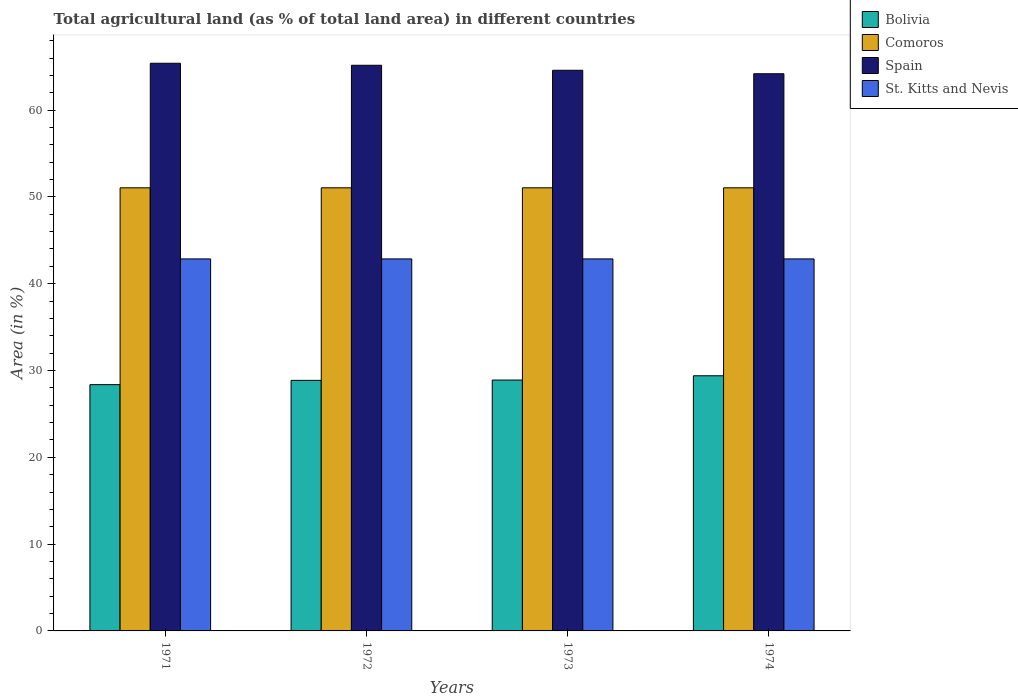How many different coloured bars are there?
Offer a very short reply. 4. What is the label of the 1st group of bars from the left?
Your answer should be compact. 1971. What is the percentage of agricultural land in Comoros in 1974?
Your response must be concise. 51.05. Across all years, what is the maximum percentage of agricultural land in Bolivia?
Your answer should be compact. 29.39. Across all years, what is the minimum percentage of agricultural land in Bolivia?
Offer a very short reply. 28.37. In which year was the percentage of agricultural land in St. Kitts and Nevis minimum?
Make the answer very short. 1971. What is the total percentage of agricultural land in Comoros in the graph?
Keep it short and to the point. 204.19. What is the difference between the percentage of agricultural land in Comoros in 1974 and the percentage of agricultural land in Bolivia in 1972?
Provide a short and direct response. 22.18. What is the average percentage of agricultural land in St. Kitts and Nevis per year?
Ensure brevity in your answer.  42.86. In the year 1971, what is the difference between the percentage of agricultural land in Bolivia and percentage of agricultural land in Spain?
Provide a succinct answer. -37.03. In how many years, is the percentage of agricultural land in Bolivia greater than 12 %?
Offer a terse response. 4. What is the ratio of the percentage of agricultural land in Comoros in 1971 to that in 1972?
Your response must be concise. 1. Is the difference between the percentage of agricultural land in Bolivia in 1973 and 1974 greater than the difference between the percentage of agricultural land in Spain in 1973 and 1974?
Offer a terse response. No. What is the difference between the highest and the second highest percentage of agricultural land in Comoros?
Provide a short and direct response. 0. Is the sum of the percentage of agricultural land in St. Kitts and Nevis in 1972 and 1973 greater than the maximum percentage of agricultural land in Comoros across all years?
Make the answer very short. Yes. Is it the case that in every year, the sum of the percentage of agricultural land in Bolivia and percentage of agricultural land in Comoros is greater than the sum of percentage of agricultural land in Spain and percentage of agricultural land in St. Kitts and Nevis?
Your response must be concise. No. What does the 1st bar from the left in 1971 represents?
Give a very brief answer. Bolivia. What does the 2nd bar from the right in 1972 represents?
Give a very brief answer. Spain. Are all the bars in the graph horizontal?
Your response must be concise. No. What is the difference between two consecutive major ticks on the Y-axis?
Provide a succinct answer. 10. Does the graph contain grids?
Provide a succinct answer. No. What is the title of the graph?
Offer a very short reply. Total agricultural land (as % of total land area) in different countries. What is the label or title of the X-axis?
Your response must be concise. Years. What is the label or title of the Y-axis?
Your response must be concise. Area (in %). What is the Area (in %) in Bolivia in 1971?
Provide a short and direct response. 28.37. What is the Area (in %) in Comoros in 1971?
Your response must be concise. 51.05. What is the Area (in %) in Spain in 1971?
Offer a very short reply. 65.4. What is the Area (in %) in St. Kitts and Nevis in 1971?
Your answer should be compact. 42.86. What is the Area (in %) of Bolivia in 1972?
Provide a short and direct response. 28.87. What is the Area (in %) in Comoros in 1972?
Your answer should be compact. 51.05. What is the Area (in %) of Spain in 1972?
Your answer should be compact. 65.16. What is the Area (in %) of St. Kitts and Nevis in 1972?
Ensure brevity in your answer.  42.86. What is the Area (in %) in Bolivia in 1973?
Make the answer very short. 28.9. What is the Area (in %) in Comoros in 1973?
Your answer should be compact. 51.05. What is the Area (in %) in Spain in 1973?
Ensure brevity in your answer.  64.59. What is the Area (in %) of St. Kitts and Nevis in 1973?
Provide a succinct answer. 42.86. What is the Area (in %) of Bolivia in 1974?
Make the answer very short. 29.39. What is the Area (in %) in Comoros in 1974?
Keep it short and to the point. 51.05. What is the Area (in %) of Spain in 1974?
Offer a terse response. 64.19. What is the Area (in %) of St. Kitts and Nevis in 1974?
Keep it short and to the point. 42.86. Across all years, what is the maximum Area (in %) of Bolivia?
Offer a terse response. 29.39. Across all years, what is the maximum Area (in %) in Comoros?
Make the answer very short. 51.05. Across all years, what is the maximum Area (in %) of Spain?
Give a very brief answer. 65.4. Across all years, what is the maximum Area (in %) of St. Kitts and Nevis?
Your response must be concise. 42.86. Across all years, what is the minimum Area (in %) of Bolivia?
Provide a short and direct response. 28.37. Across all years, what is the minimum Area (in %) in Comoros?
Give a very brief answer. 51.05. Across all years, what is the minimum Area (in %) of Spain?
Your answer should be compact. 64.19. Across all years, what is the minimum Area (in %) of St. Kitts and Nevis?
Provide a short and direct response. 42.86. What is the total Area (in %) in Bolivia in the graph?
Offer a very short reply. 115.53. What is the total Area (in %) in Comoros in the graph?
Offer a terse response. 204.19. What is the total Area (in %) of Spain in the graph?
Keep it short and to the point. 259.34. What is the total Area (in %) in St. Kitts and Nevis in the graph?
Give a very brief answer. 171.43. What is the difference between the Area (in %) of Bolivia in 1971 and that in 1972?
Make the answer very short. -0.49. What is the difference between the Area (in %) in Spain in 1971 and that in 1972?
Offer a very short reply. 0.23. What is the difference between the Area (in %) in Bolivia in 1971 and that in 1973?
Ensure brevity in your answer.  -0.53. What is the difference between the Area (in %) in Comoros in 1971 and that in 1973?
Ensure brevity in your answer.  0. What is the difference between the Area (in %) of Spain in 1971 and that in 1973?
Offer a very short reply. 0.81. What is the difference between the Area (in %) of Bolivia in 1971 and that in 1974?
Provide a short and direct response. -1.02. What is the difference between the Area (in %) of Comoros in 1971 and that in 1974?
Keep it short and to the point. 0. What is the difference between the Area (in %) in Spain in 1971 and that in 1974?
Offer a very short reply. 1.21. What is the difference between the Area (in %) of St. Kitts and Nevis in 1971 and that in 1974?
Provide a short and direct response. 0. What is the difference between the Area (in %) of Bolivia in 1972 and that in 1973?
Keep it short and to the point. -0.04. What is the difference between the Area (in %) in Comoros in 1972 and that in 1973?
Ensure brevity in your answer.  0. What is the difference between the Area (in %) of Spain in 1972 and that in 1973?
Give a very brief answer. 0.58. What is the difference between the Area (in %) of Bolivia in 1972 and that in 1974?
Give a very brief answer. -0.53. What is the difference between the Area (in %) in Comoros in 1972 and that in 1974?
Provide a short and direct response. 0. What is the difference between the Area (in %) of Spain in 1972 and that in 1974?
Your answer should be very brief. 0.98. What is the difference between the Area (in %) in St. Kitts and Nevis in 1972 and that in 1974?
Offer a terse response. 0. What is the difference between the Area (in %) of Bolivia in 1973 and that in 1974?
Make the answer very short. -0.49. What is the difference between the Area (in %) of Comoros in 1973 and that in 1974?
Your answer should be very brief. 0. What is the difference between the Area (in %) in Spain in 1973 and that in 1974?
Your answer should be very brief. 0.4. What is the difference between the Area (in %) in Bolivia in 1971 and the Area (in %) in Comoros in 1972?
Give a very brief answer. -22.68. What is the difference between the Area (in %) of Bolivia in 1971 and the Area (in %) of Spain in 1972?
Provide a short and direct response. -36.79. What is the difference between the Area (in %) in Bolivia in 1971 and the Area (in %) in St. Kitts and Nevis in 1972?
Offer a terse response. -14.49. What is the difference between the Area (in %) of Comoros in 1971 and the Area (in %) of Spain in 1972?
Keep it short and to the point. -14.12. What is the difference between the Area (in %) in Comoros in 1971 and the Area (in %) in St. Kitts and Nevis in 1972?
Keep it short and to the point. 8.19. What is the difference between the Area (in %) of Spain in 1971 and the Area (in %) of St. Kitts and Nevis in 1972?
Ensure brevity in your answer.  22.54. What is the difference between the Area (in %) in Bolivia in 1971 and the Area (in %) in Comoros in 1973?
Offer a terse response. -22.68. What is the difference between the Area (in %) in Bolivia in 1971 and the Area (in %) in Spain in 1973?
Your answer should be very brief. -36.22. What is the difference between the Area (in %) in Bolivia in 1971 and the Area (in %) in St. Kitts and Nevis in 1973?
Your answer should be very brief. -14.49. What is the difference between the Area (in %) of Comoros in 1971 and the Area (in %) of Spain in 1973?
Provide a succinct answer. -13.54. What is the difference between the Area (in %) in Comoros in 1971 and the Area (in %) in St. Kitts and Nevis in 1973?
Make the answer very short. 8.19. What is the difference between the Area (in %) in Spain in 1971 and the Area (in %) in St. Kitts and Nevis in 1973?
Offer a very short reply. 22.54. What is the difference between the Area (in %) of Bolivia in 1971 and the Area (in %) of Comoros in 1974?
Your answer should be very brief. -22.68. What is the difference between the Area (in %) of Bolivia in 1971 and the Area (in %) of Spain in 1974?
Offer a terse response. -35.82. What is the difference between the Area (in %) of Bolivia in 1971 and the Area (in %) of St. Kitts and Nevis in 1974?
Your response must be concise. -14.49. What is the difference between the Area (in %) of Comoros in 1971 and the Area (in %) of Spain in 1974?
Make the answer very short. -13.14. What is the difference between the Area (in %) of Comoros in 1971 and the Area (in %) of St. Kitts and Nevis in 1974?
Provide a succinct answer. 8.19. What is the difference between the Area (in %) in Spain in 1971 and the Area (in %) in St. Kitts and Nevis in 1974?
Make the answer very short. 22.54. What is the difference between the Area (in %) in Bolivia in 1972 and the Area (in %) in Comoros in 1973?
Provide a succinct answer. -22.18. What is the difference between the Area (in %) in Bolivia in 1972 and the Area (in %) in Spain in 1973?
Your response must be concise. -35.72. What is the difference between the Area (in %) in Bolivia in 1972 and the Area (in %) in St. Kitts and Nevis in 1973?
Provide a succinct answer. -13.99. What is the difference between the Area (in %) of Comoros in 1972 and the Area (in %) of Spain in 1973?
Provide a succinct answer. -13.54. What is the difference between the Area (in %) of Comoros in 1972 and the Area (in %) of St. Kitts and Nevis in 1973?
Offer a very short reply. 8.19. What is the difference between the Area (in %) in Spain in 1972 and the Area (in %) in St. Kitts and Nevis in 1973?
Your answer should be very brief. 22.31. What is the difference between the Area (in %) of Bolivia in 1972 and the Area (in %) of Comoros in 1974?
Ensure brevity in your answer.  -22.18. What is the difference between the Area (in %) of Bolivia in 1972 and the Area (in %) of Spain in 1974?
Give a very brief answer. -35.32. What is the difference between the Area (in %) of Bolivia in 1972 and the Area (in %) of St. Kitts and Nevis in 1974?
Your answer should be compact. -13.99. What is the difference between the Area (in %) in Comoros in 1972 and the Area (in %) in Spain in 1974?
Give a very brief answer. -13.14. What is the difference between the Area (in %) in Comoros in 1972 and the Area (in %) in St. Kitts and Nevis in 1974?
Offer a very short reply. 8.19. What is the difference between the Area (in %) of Spain in 1972 and the Area (in %) of St. Kitts and Nevis in 1974?
Give a very brief answer. 22.31. What is the difference between the Area (in %) in Bolivia in 1973 and the Area (in %) in Comoros in 1974?
Your answer should be compact. -22.15. What is the difference between the Area (in %) in Bolivia in 1973 and the Area (in %) in Spain in 1974?
Provide a short and direct response. -35.29. What is the difference between the Area (in %) of Bolivia in 1973 and the Area (in %) of St. Kitts and Nevis in 1974?
Keep it short and to the point. -13.96. What is the difference between the Area (in %) in Comoros in 1973 and the Area (in %) in Spain in 1974?
Your answer should be compact. -13.14. What is the difference between the Area (in %) of Comoros in 1973 and the Area (in %) of St. Kitts and Nevis in 1974?
Ensure brevity in your answer.  8.19. What is the difference between the Area (in %) of Spain in 1973 and the Area (in %) of St. Kitts and Nevis in 1974?
Keep it short and to the point. 21.73. What is the average Area (in %) in Bolivia per year?
Keep it short and to the point. 28.88. What is the average Area (in %) of Comoros per year?
Provide a short and direct response. 51.05. What is the average Area (in %) of Spain per year?
Your response must be concise. 64.83. What is the average Area (in %) of St. Kitts and Nevis per year?
Make the answer very short. 42.86. In the year 1971, what is the difference between the Area (in %) in Bolivia and Area (in %) in Comoros?
Provide a succinct answer. -22.68. In the year 1971, what is the difference between the Area (in %) in Bolivia and Area (in %) in Spain?
Make the answer very short. -37.03. In the year 1971, what is the difference between the Area (in %) of Bolivia and Area (in %) of St. Kitts and Nevis?
Your answer should be compact. -14.49. In the year 1971, what is the difference between the Area (in %) of Comoros and Area (in %) of Spain?
Ensure brevity in your answer.  -14.35. In the year 1971, what is the difference between the Area (in %) in Comoros and Area (in %) in St. Kitts and Nevis?
Your answer should be very brief. 8.19. In the year 1971, what is the difference between the Area (in %) of Spain and Area (in %) of St. Kitts and Nevis?
Your answer should be very brief. 22.54. In the year 1972, what is the difference between the Area (in %) of Bolivia and Area (in %) of Comoros?
Keep it short and to the point. -22.18. In the year 1972, what is the difference between the Area (in %) in Bolivia and Area (in %) in Spain?
Your answer should be very brief. -36.3. In the year 1972, what is the difference between the Area (in %) in Bolivia and Area (in %) in St. Kitts and Nevis?
Give a very brief answer. -13.99. In the year 1972, what is the difference between the Area (in %) of Comoros and Area (in %) of Spain?
Your answer should be very brief. -14.12. In the year 1972, what is the difference between the Area (in %) in Comoros and Area (in %) in St. Kitts and Nevis?
Offer a very short reply. 8.19. In the year 1972, what is the difference between the Area (in %) in Spain and Area (in %) in St. Kitts and Nevis?
Your answer should be very brief. 22.31. In the year 1973, what is the difference between the Area (in %) in Bolivia and Area (in %) in Comoros?
Provide a succinct answer. -22.15. In the year 1973, what is the difference between the Area (in %) in Bolivia and Area (in %) in Spain?
Offer a very short reply. -35.69. In the year 1973, what is the difference between the Area (in %) of Bolivia and Area (in %) of St. Kitts and Nevis?
Your answer should be very brief. -13.96. In the year 1973, what is the difference between the Area (in %) in Comoros and Area (in %) in Spain?
Make the answer very short. -13.54. In the year 1973, what is the difference between the Area (in %) in Comoros and Area (in %) in St. Kitts and Nevis?
Keep it short and to the point. 8.19. In the year 1973, what is the difference between the Area (in %) of Spain and Area (in %) of St. Kitts and Nevis?
Offer a terse response. 21.73. In the year 1974, what is the difference between the Area (in %) in Bolivia and Area (in %) in Comoros?
Offer a terse response. -21.65. In the year 1974, what is the difference between the Area (in %) of Bolivia and Area (in %) of Spain?
Ensure brevity in your answer.  -34.79. In the year 1974, what is the difference between the Area (in %) of Bolivia and Area (in %) of St. Kitts and Nevis?
Your response must be concise. -13.46. In the year 1974, what is the difference between the Area (in %) in Comoros and Area (in %) in Spain?
Provide a succinct answer. -13.14. In the year 1974, what is the difference between the Area (in %) of Comoros and Area (in %) of St. Kitts and Nevis?
Provide a succinct answer. 8.19. In the year 1974, what is the difference between the Area (in %) of Spain and Area (in %) of St. Kitts and Nevis?
Keep it short and to the point. 21.33. What is the ratio of the Area (in %) of Bolivia in 1971 to that in 1972?
Make the answer very short. 0.98. What is the ratio of the Area (in %) of Comoros in 1971 to that in 1972?
Your answer should be compact. 1. What is the ratio of the Area (in %) of Bolivia in 1971 to that in 1973?
Your answer should be compact. 0.98. What is the ratio of the Area (in %) in Comoros in 1971 to that in 1973?
Your response must be concise. 1. What is the ratio of the Area (in %) in Spain in 1971 to that in 1973?
Ensure brevity in your answer.  1.01. What is the ratio of the Area (in %) of St. Kitts and Nevis in 1971 to that in 1973?
Give a very brief answer. 1. What is the ratio of the Area (in %) of Bolivia in 1971 to that in 1974?
Make the answer very short. 0.97. What is the ratio of the Area (in %) of Spain in 1971 to that in 1974?
Make the answer very short. 1.02. What is the ratio of the Area (in %) of St. Kitts and Nevis in 1971 to that in 1974?
Offer a terse response. 1. What is the ratio of the Area (in %) in Comoros in 1972 to that in 1973?
Offer a terse response. 1. What is the ratio of the Area (in %) of Spain in 1972 to that in 1973?
Keep it short and to the point. 1.01. What is the ratio of the Area (in %) in Comoros in 1972 to that in 1974?
Keep it short and to the point. 1. What is the ratio of the Area (in %) in Spain in 1972 to that in 1974?
Give a very brief answer. 1.02. What is the ratio of the Area (in %) of St. Kitts and Nevis in 1972 to that in 1974?
Offer a terse response. 1. What is the ratio of the Area (in %) in Bolivia in 1973 to that in 1974?
Your answer should be compact. 0.98. What is the ratio of the Area (in %) of Comoros in 1973 to that in 1974?
Make the answer very short. 1. What is the difference between the highest and the second highest Area (in %) of Bolivia?
Offer a very short reply. 0.49. What is the difference between the highest and the second highest Area (in %) of Comoros?
Ensure brevity in your answer.  0. What is the difference between the highest and the second highest Area (in %) in Spain?
Your response must be concise. 0.23. What is the difference between the highest and the second highest Area (in %) of St. Kitts and Nevis?
Give a very brief answer. 0. What is the difference between the highest and the lowest Area (in %) in Bolivia?
Your answer should be compact. 1.02. What is the difference between the highest and the lowest Area (in %) of Spain?
Make the answer very short. 1.21. 